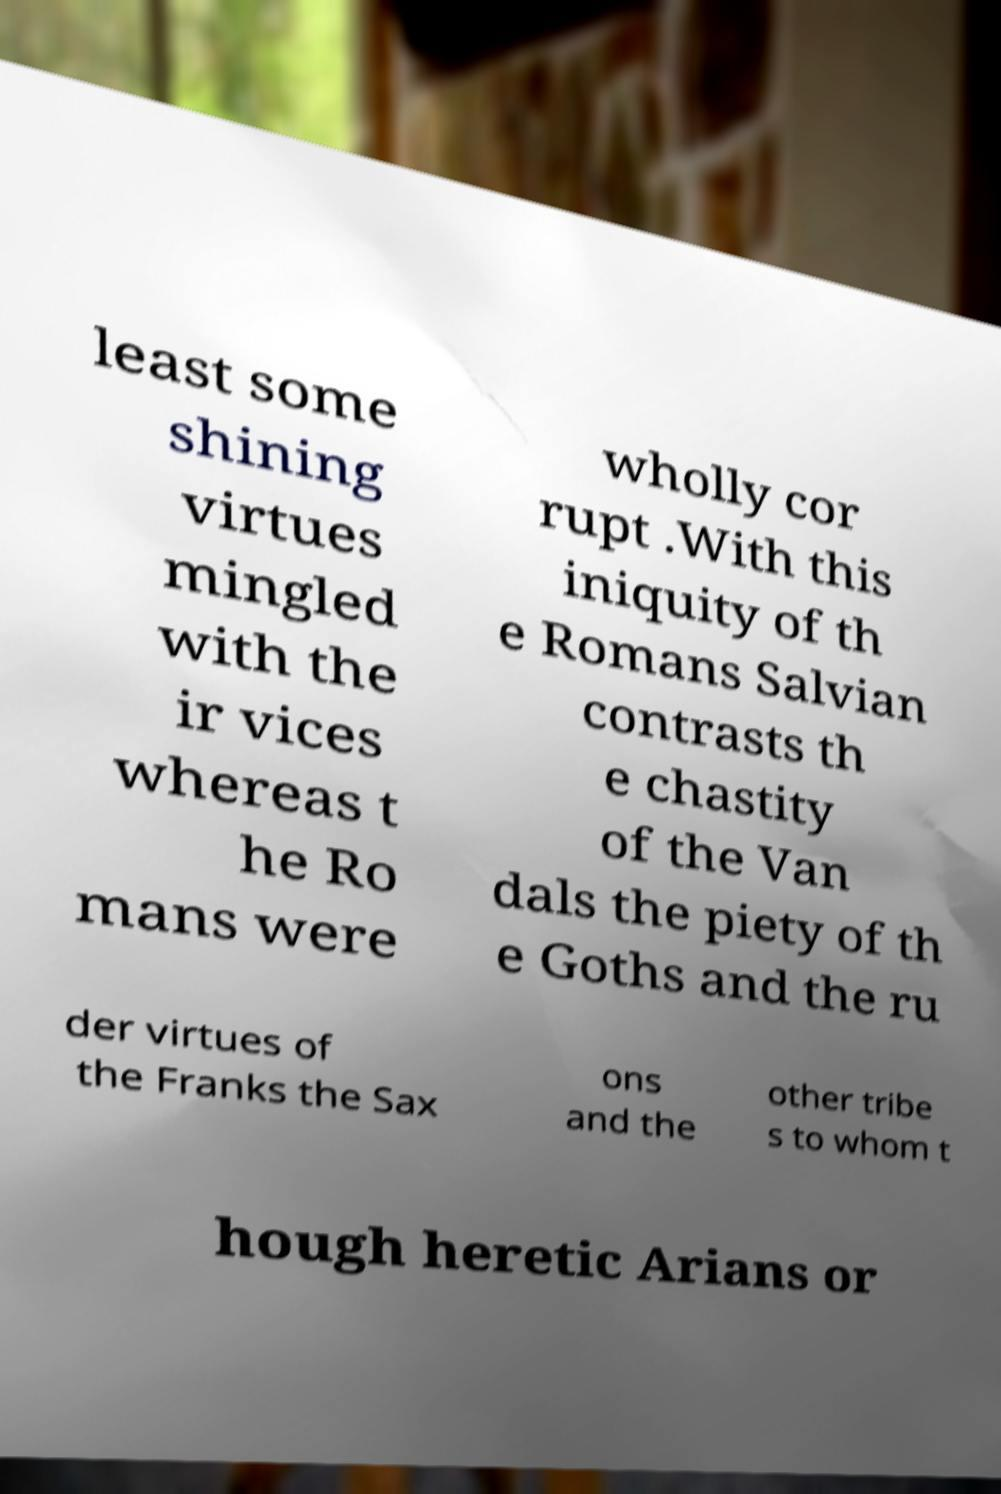Could you extract and type out the text from this image? least some shining virtues mingled with the ir vices whereas t he Ro mans were wholly cor rupt .With this iniquity of th e Romans Salvian contrasts th e chastity of the Van dals the piety of th e Goths and the ru der virtues of the Franks the Sax ons and the other tribe s to whom t hough heretic Arians or 